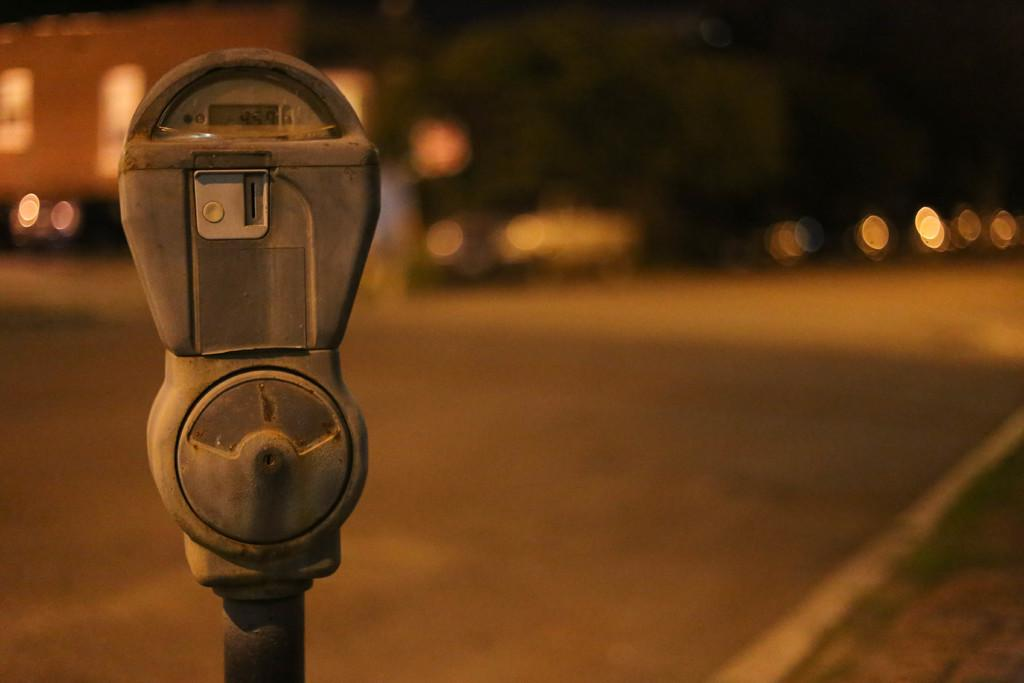What can be seen in the image? There is an object in the image. What is the surface beneath the object? The ground is visible in the image. How would you describe the background of the image? The background of the image is blurred. What type of shoes can be seen in the image? There are no shoes present in the image. What is the rail used for in the image? There is no rail present in the image. How is the butter being used in the image? There is no butter present in the image. 